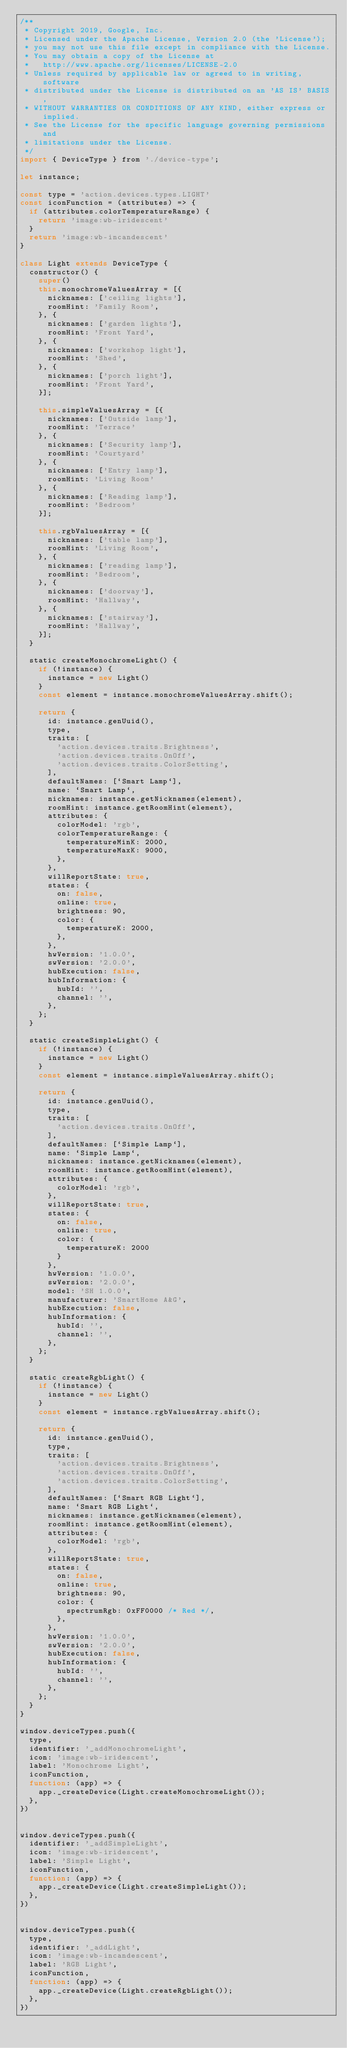<code> <loc_0><loc_0><loc_500><loc_500><_JavaScript_>/**
 * Copyright 2019, Google, Inc.
 * Licensed under the Apache License, Version 2.0 (the 'License');
 * you may not use this file except in compliance with the License.
 * You may obtain a copy of the License at
 *   http://www.apache.org/licenses/LICENSE-2.0
 * Unless required by applicable law or agreed to in writing, software
 * distributed under the License is distributed on an 'AS IS' BASIS,
 * WITHOUT WARRANTIES OR CONDITIONS OF ANY KIND, either express or implied.
 * See the License for the specific language governing permissions and
 * limitations under the License.
 */
import { DeviceType } from './device-type';

let instance;

const type = 'action.devices.types.LIGHT'
const iconFunction = (attributes) => {
  if (attributes.colorTemperatureRange) {
    return 'image:wb-iridescent'
  }
  return 'image:wb-incandescent'
}

class Light extends DeviceType {
  constructor() {
    super()
    this.monochromeValuesArray = [{
      nicknames: ['ceiling lights'],
      roomHint: 'Family Room',
    }, {
      nicknames: ['garden lights'],
      roomHint: 'Front Yard',
    }, {
      nicknames: ['workshop light'],
      roomHint: 'Shed',
    }, {
      nicknames: ['porch light'],
      roomHint: 'Front Yard',
    }];

    this.simpleValuesArray = [{
      nicknames: ['Outside lamp'],
      roomHint: 'Terrace'
    }, {
      nicknames: ['Security lamp'],
      roomHint: 'Courtyard'
    }, {
      nicknames: ['Entry lamp'],
      roomHint: 'Living Room'
    }, {
      nicknames: ['Reading lamp'],
      roomHint: 'Bedroom'
    }];

    this.rgbValuesArray = [{
      nicknames: ['table lamp'],
      roomHint: 'Living Room',
    }, {
      nicknames: ['reading lamp'],
      roomHint: 'Bedroom',
    }, {
      nicknames: ['doorway'],
      roomHint: 'Hallway',
    }, {
      nicknames: ['stairway'],
      roomHint: 'Hallway',
    }];
  }

  static createMonochromeLight() {
    if (!instance) {
      instance = new Light()
    }
    const element = instance.monochromeValuesArray.shift();

    return {
      id: instance.genUuid(),
      type,
      traits: [
        'action.devices.traits.Brightness',
        'action.devices.traits.OnOff',
        'action.devices.traits.ColorSetting',
      ],
      defaultNames: [`Smart Lamp`],
      name: `Smart Lamp`,
      nicknames: instance.getNicknames(element),
      roomHint: instance.getRoomHint(element),
      attributes: {
        colorModel: 'rgb',
        colorTemperatureRange: {
          temperatureMinK: 2000,
          temperatureMaxK: 9000,
        },
      },
      willReportState: true,
      states: {
        on: false,
        online: true,
        brightness: 90,
        color: {
          temperatureK: 2000,
        },
      },
      hwVersion: '1.0.0',
      swVersion: '2.0.0',
      hubExecution: false,
      hubInformation: {
        hubId: '',
        channel: '',
      },
    };
  }

  static createSimpleLight() {
    if (!instance) {
      instance = new Light()
    }
    const element = instance.simpleValuesArray.shift();

    return {
      id: instance.genUuid(),
      type,
      traits: [
        'action.devices.traits.OnOff',
      ],
      defaultNames: [`Simple Lamp`],
      name: `Simple Lamp`,
      nicknames: instance.getNicknames(element),
      roomHint: instance.getRoomHint(element),
      attributes: {
        colorModel: 'rgb',
      },
      willReportState: true,
      states: {
        on: false,
        online: true,
        color: {
          temperatureK: 2000
        }
      },
      hwVersion: '1.0.0',
      swVersion: '2.0.0',
      model: 'SH 1.0.0',
      manufacturer: 'SmartHome A&G',
      hubExecution: false,
      hubInformation: {
        hubId: '',
        channel: '',
      },
    };
  }

  static createRgbLight() {
    if (!instance) {
      instance = new Light()
    }
    const element = instance.rgbValuesArray.shift();

    return {
      id: instance.genUuid(),
      type,
      traits: [
        'action.devices.traits.Brightness',
        'action.devices.traits.OnOff',
        'action.devices.traits.ColorSetting',
      ],
      defaultNames: [`Smart RGB Light`],
      name: `Smart RGB Light`,
      nicknames: instance.getNicknames(element),
      roomHint: instance.getRoomHint(element),
      attributes: {
        colorModel: 'rgb',
      },
      willReportState: true,
      states: {
        on: false,
        online: true,
        brightness: 90,
        color: {
          spectrumRgb: 0xFF0000 /* Red */,
        },
      },
      hwVersion: '1.0.0',
      swVersion: '2.0.0',
      hubExecution: false,
      hubInformation: {
        hubId: '',
        channel: '',
      },
    };
  }
}

window.deviceTypes.push({
  type,
  identifier: '_addMonochromeLight',
  icon: 'image:wb-iridescent',
  label: 'Monochrome Light',
  iconFunction,
  function: (app) => {
    app._createDevice(Light.createMonochromeLight());
  },
})


window.deviceTypes.push({
  identifier: '_addSimpleLight',
  icon: 'image:wb-iridescent',
  label: 'Simple Light',
  iconFunction,
  function: (app) => {
    app._createDevice(Light.createSimpleLight());
  },
})


window.deviceTypes.push({
  type,
  identifier: '_addLight',
  icon: 'image:wb-incandescent',
  label: 'RGB Light',
  iconFunction,
  function: (app) => {
    app._createDevice(Light.createRgbLight());
  },
})
</code> 